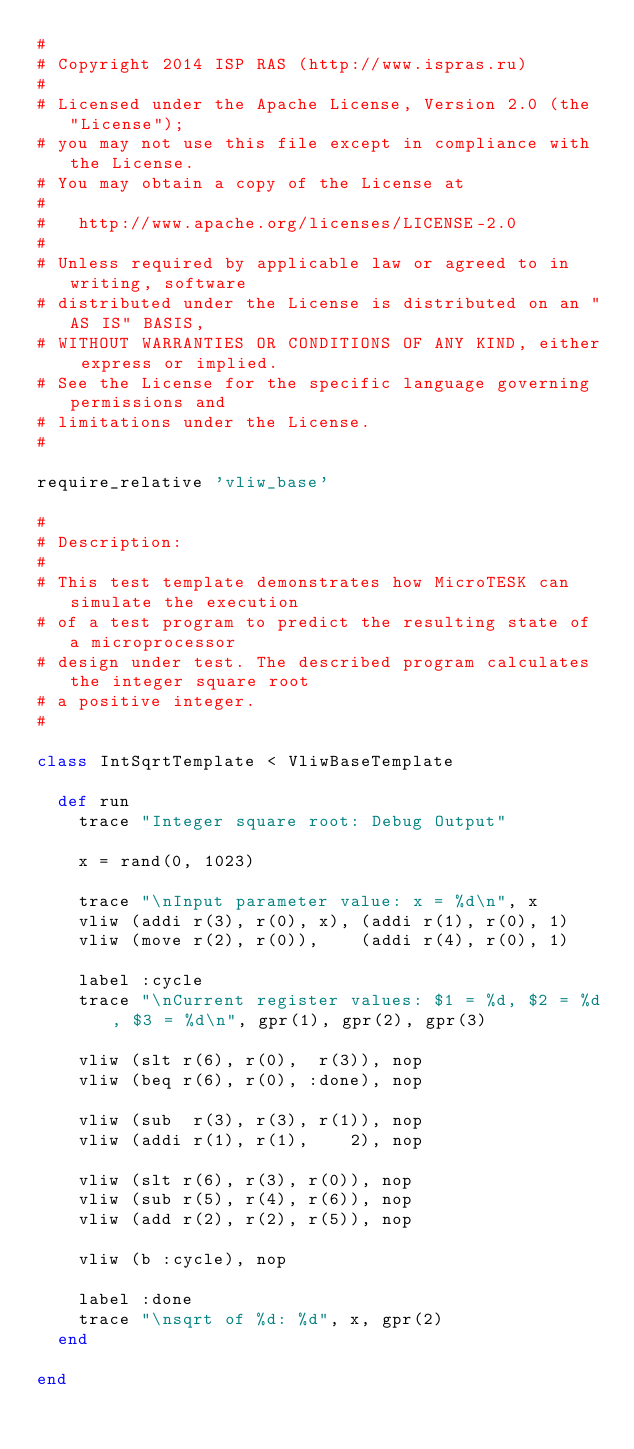<code> <loc_0><loc_0><loc_500><loc_500><_Ruby_>#
# Copyright 2014 ISP RAS (http://www.ispras.ru)
#
# Licensed under the Apache License, Version 2.0 (the "License");
# you may not use this file except in compliance with the License.
# You may obtain a copy of the License at
#
#   http://www.apache.org/licenses/LICENSE-2.0
#
# Unless required by applicable law or agreed to in writing, software
# distributed under the License is distributed on an "AS IS" BASIS,
# WITHOUT WARRANTIES OR CONDITIONS OF ANY KIND, either express or implied.
# See the License for the specific language governing permissions and
# limitations under the License.
#

require_relative 'vliw_base'

#
# Description:
#
# This test template demonstrates how MicroTESK can simulate the execution
# of a test program to predict the resulting state of a microprocessor
# design under test. The described program calculates the integer square root
# a positive integer.
#

class IntSqrtTemplate < VliwBaseTemplate

  def run
    trace "Integer square root: Debug Output"

    x = rand(0, 1023)

    trace "\nInput parameter value: x = %d\n", x
    vliw (addi r(3), r(0), x), (addi r(1), r(0), 1)
    vliw (move r(2), r(0)),    (addi r(4), r(0), 1)

    label :cycle
    trace "\nCurrent register values: $1 = %d, $2 = %d, $3 = %d\n", gpr(1), gpr(2), gpr(3)

    vliw (slt r(6), r(0),  r(3)), nop
    vliw (beq r(6), r(0), :done), nop

    vliw (sub  r(3), r(3), r(1)), nop
    vliw (addi r(1), r(1),    2), nop

    vliw (slt r(6), r(3), r(0)), nop
    vliw (sub r(5), r(4), r(6)), nop
    vliw (add r(2), r(2), r(5)), nop

    vliw (b :cycle), nop

    label :done
    trace "\nsqrt of %d: %d", x, gpr(2)
  end

end
</code> 